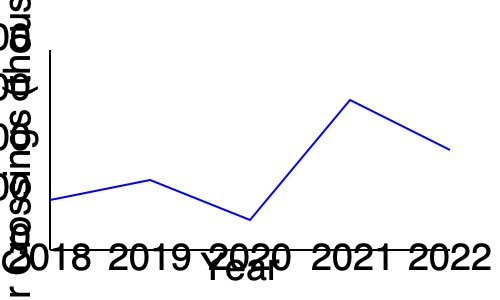Based on the line graph showing border crossing trends from 2018 to 2022, which year had the highest number of border crossings, and what was the approximate number of crossings in thousands? To answer this question, we need to analyze the line graph step by step:

1. The y-axis represents the number of border crossings in thousands.
2. The x-axis shows the years from 2018 to 2022.
3. The blue line represents the trend of border crossings over time.
4. We need to identify the highest point on the graph:
   - 2018 (leftmost point): approximately 150,000 crossings
   - 2019: slightly lower than 2018
   - 2020: higher than 2019 but lower than 2018
   - 2021: clearly the highest point on the graph
   - 2022: higher than 2018-2020 but lower than 2021
5. The highest point corresponds to 2021.
6. To estimate the number of crossings in 2021:
   - The point is slightly above the 300,000 mark on the y-axis
   - It's approximately halfway between 300,000 and 400,000
   - Therefore, we can estimate it to be around 350,000 crossings

Thus, 2021 had the highest number of border crossings, with approximately 350,000 crossings.
Answer: 2021, approximately 350,000 